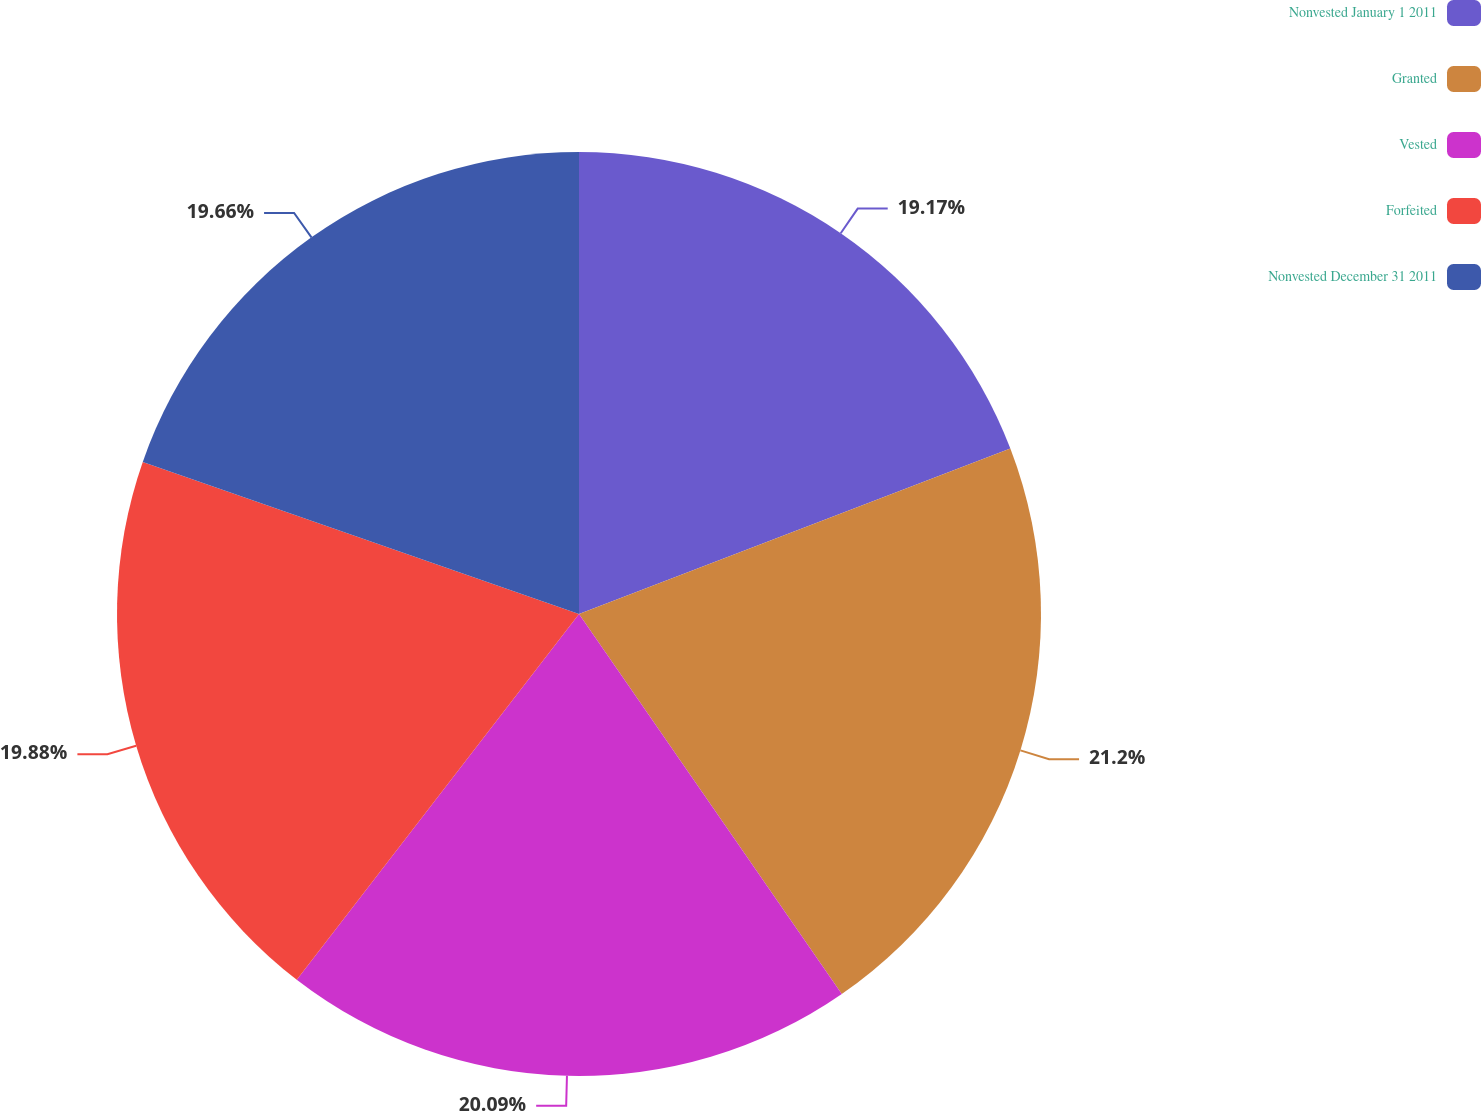Convert chart. <chart><loc_0><loc_0><loc_500><loc_500><pie_chart><fcel>Nonvested January 1 2011<fcel>Granted<fcel>Vested<fcel>Forfeited<fcel>Nonvested December 31 2011<nl><fcel>19.17%<fcel>21.2%<fcel>20.09%<fcel>19.88%<fcel>19.66%<nl></chart> 